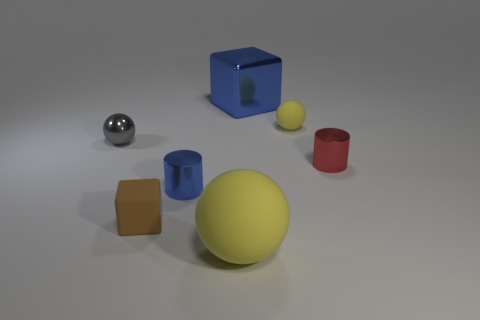Describe how light and shadow are interacting with the objects. The objects cast soft shadows on the ground, indicating a diffuse light source above. The metallic sphere reflects the most light, showcasing its smooth and shiny texture, while the matte surfaces of the other objects diffuse light more evenly. What can you tell about the texture of these objects? The objects appear to have different textures. The metallic sphere has a reflective, high-gloss finish. The yellow and blue balls seem to have a slightly matte surface. In contrast, the cube and the cylinders have flat colors with no reflection, suggesting a completely matte texture. 